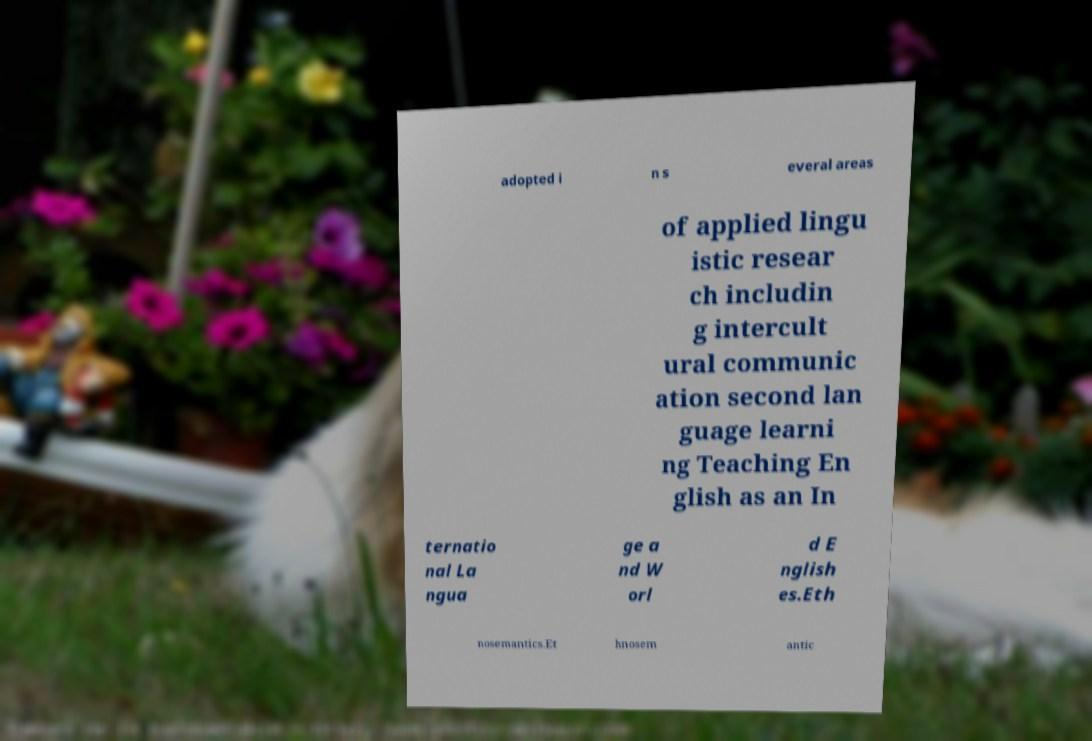What messages or text are displayed in this image? I need them in a readable, typed format. adopted i n s everal areas of applied lingu istic resear ch includin g intercult ural communic ation second lan guage learni ng Teaching En glish as an In ternatio nal La ngua ge a nd W orl d E nglish es.Eth nosemantics.Et hnosem antic 